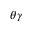Convert formula to latex. <formula><loc_0><loc_0><loc_500><loc_500>\theta \gamma</formula> 